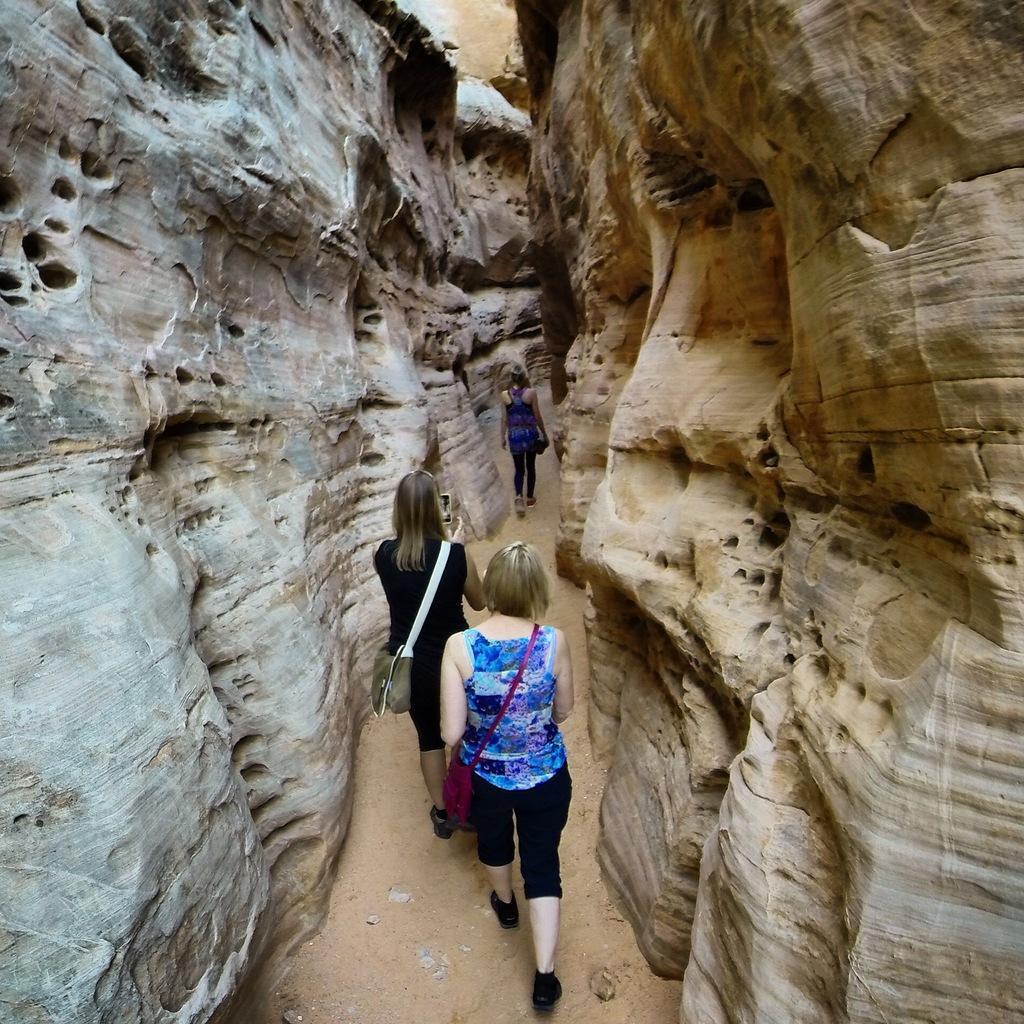How would you summarize this image in a sentence or two? In this picture we can see three women carrying bags and walking on the ground and in the background we can see rocks. 